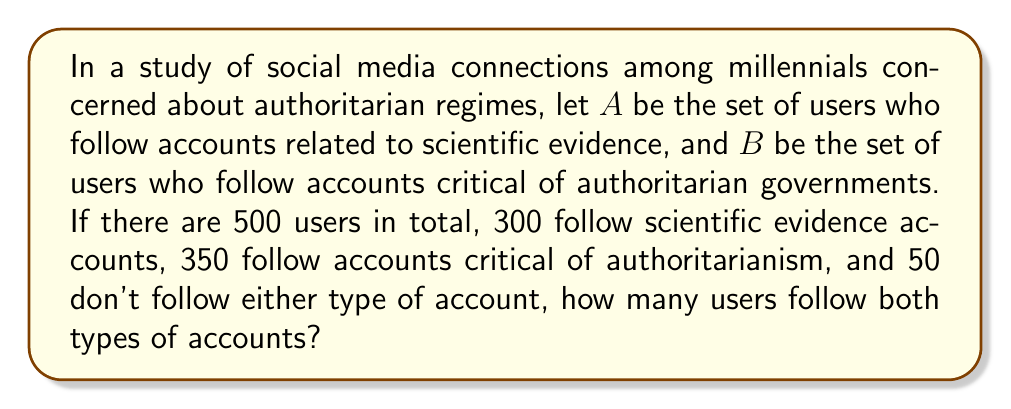Give your solution to this math problem. Let's approach this problem using set theory:

1) First, let's define our universal set $U$ as all users in the study:
   $|U| = 500$

2) We're given:
   $|A| = 300$ (users following scientific evidence accounts)
   $|B| = 350$ (users following accounts critical of authoritarianism)
   $|A' \cap B'| = 50$ (users following neither type)

3) We need to find $|A \cap B|$ (users following both types)

4) We can use the principle of inclusion-exclusion:
   $|A \cup B| = |A| + |B| - |A \cap B|$

5) We also know that $|U| = |A \cup B| + |A' \cap B'|$
   $500 = |A \cup B| + 50$
   $|A \cup B| = 450$

6) Now we can solve for $|A \cap B|$:
   $450 = 300 + 350 - |A \cap B|$
   $450 = 650 - |A \cap B|$
   $|A \cap B| = 650 - 450 = 200$

Therefore, 200 users follow both types of accounts.

This can be visualized with a Venn diagram:

[asy]
unitsize(1cm);
pair A = (0,0), B = (3,0);
real r = 2;
path c1 = circle(A,r);
path c2 = circle(B,r);
fill(c1,rgb(0.7,0.7,1));
fill(c2,rgb(1,0.7,0.7));
fill(c1,rgb(1,0.8,0.8) & rgb(0.8,0.8,1));
draw(c1);
draw(c2);
label("A",A+(-1.5,1.5));
label("B",B+(1.5,1.5));
label("100",A+(-0.7,0));
label("150",B+(0.7,0));
label("200",(1.5,0));
label("50",(4.5,0));
[/asy]
Answer: 200 users follow both types of accounts. 